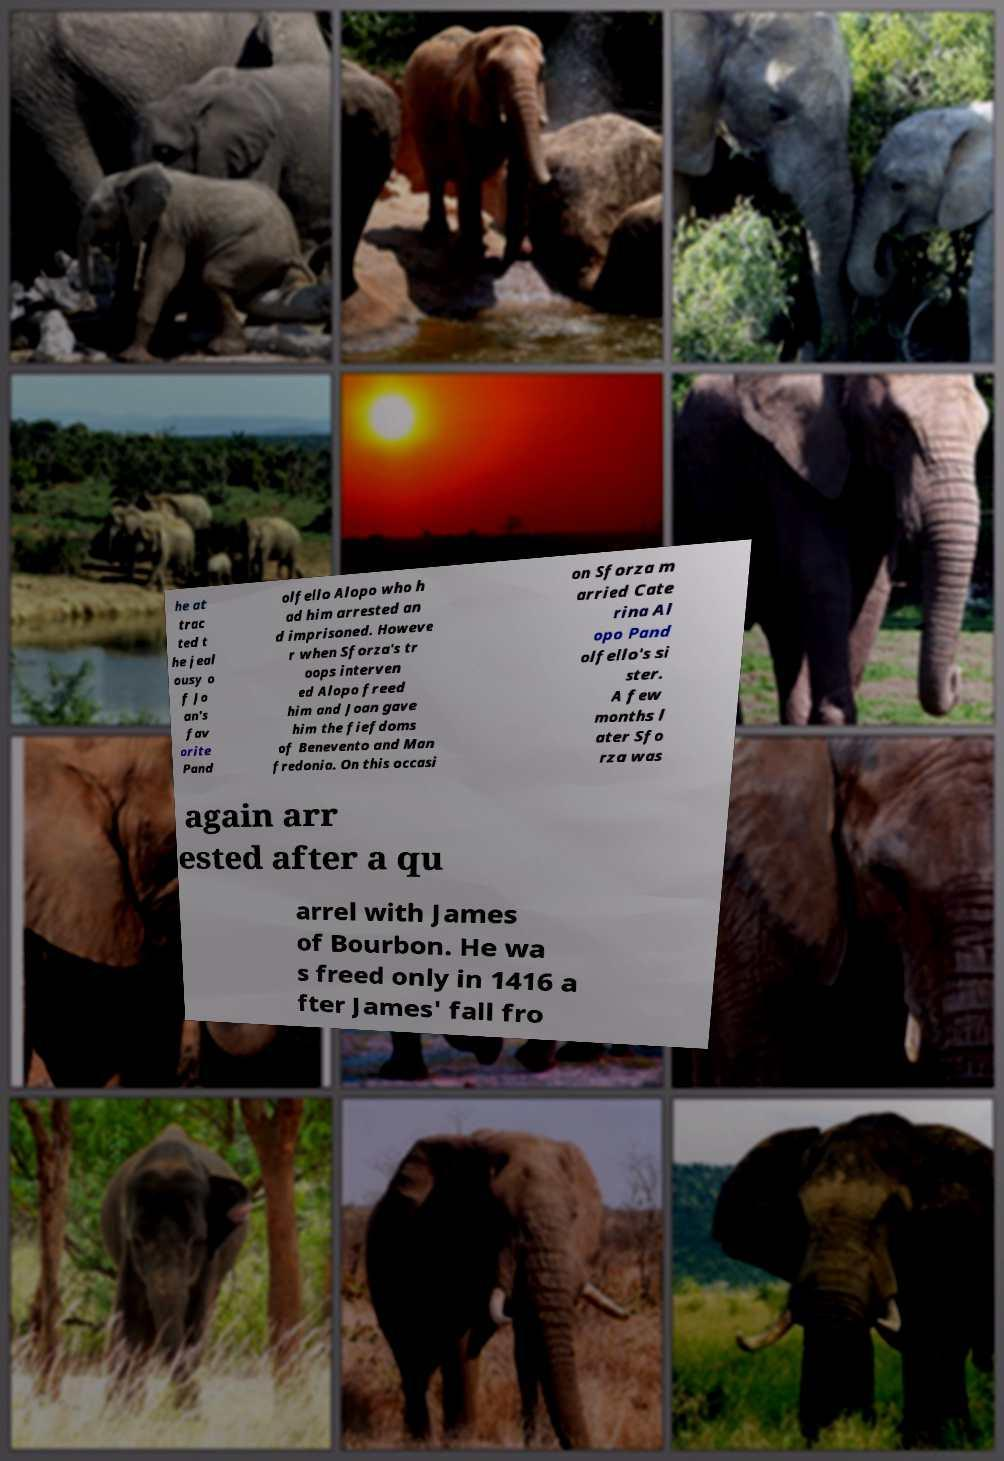Can you accurately transcribe the text from the provided image for me? he at trac ted t he jeal ousy o f Jo an's fav orite Pand olfello Alopo who h ad him arrested an d imprisoned. Howeve r when Sforza's tr oops interven ed Alopo freed him and Joan gave him the fiefdoms of Benevento and Man fredonia. On this occasi on Sforza m arried Cate rina Al opo Pand olfello's si ster. A few months l ater Sfo rza was again arr ested after a qu arrel with James of Bourbon. He wa s freed only in 1416 a fter James' fall fro 